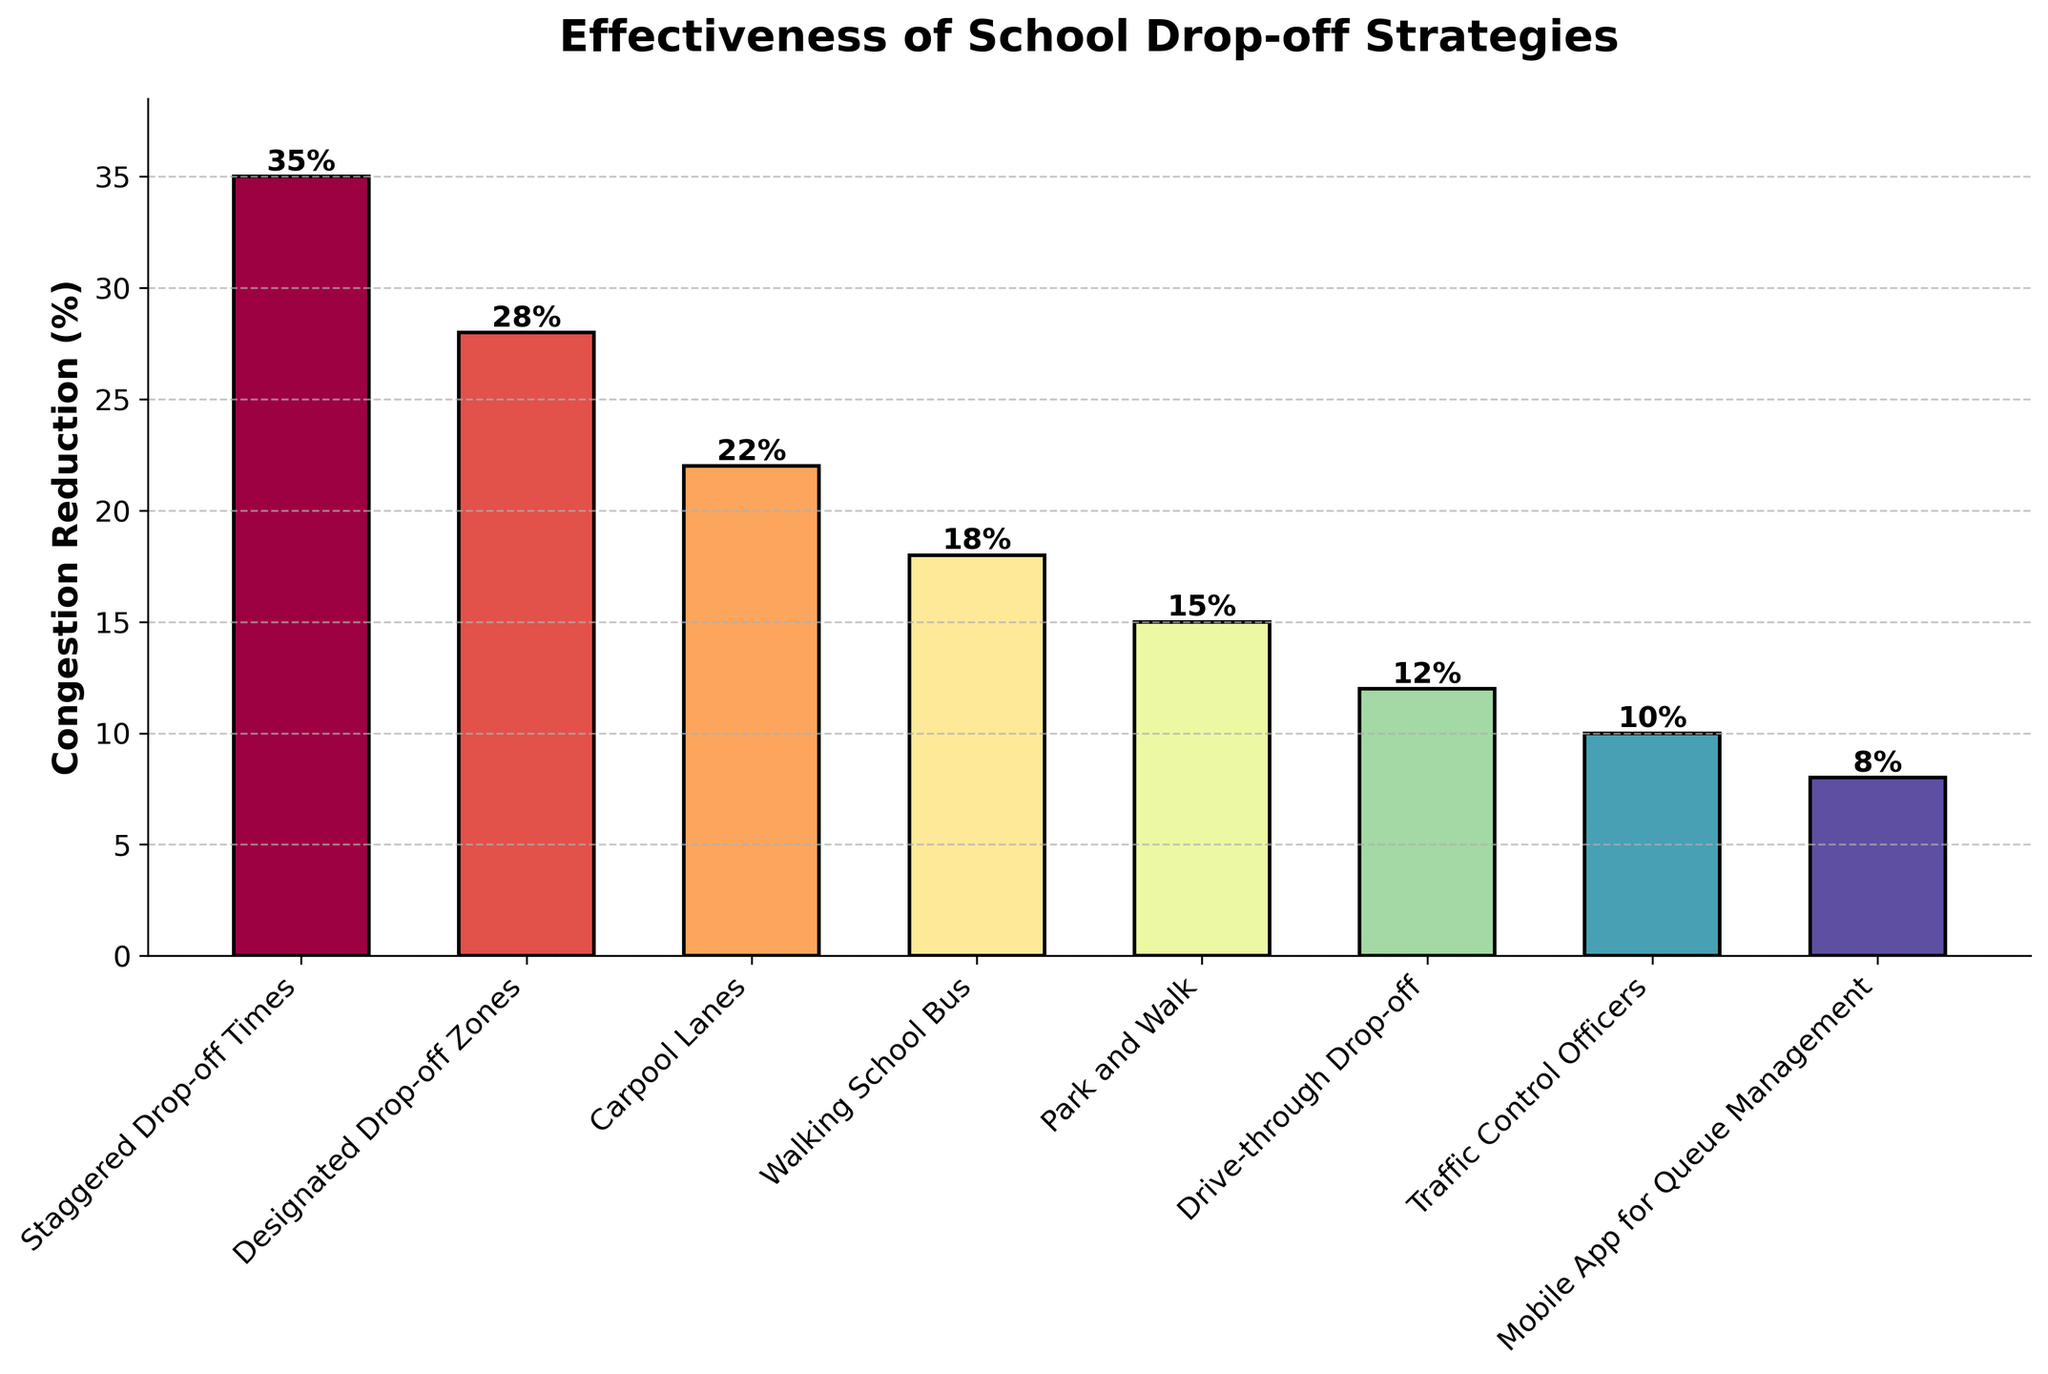Which strategy is the most effective in reducing congestion? The bar representing "Staggered Drop-off Times" is the tallest, implying the highest percentage of congestion reduction.
Answer: Staggered Drop-off Times How much more effective is "Staggered Drop-off Times" compared to "Drive-through Drop-off"? The congestion reduction for "Staggered Drop-off Times" is 35%, while for "Drive-through Drop-off" it is 12%. The difference is 35% - 12% = 23%.
Answer: 23% What is the total congestion reduction percentage of the top three strategies combined? The top three strategies are "Staggered Drop-off Times" (35%), "Designated Drop-off Zones" (28%), and "Carpool Lanes" (22%). Summing these gives 35% + 28% + 22% = 85%.
Answer: 85% Which strategy out of "Walking School Bus" and "Park and Walk" has a greater congestion reduction percentage? The bar for "Walking School Bus" shows an 18% reduction, while the bar for "Park and Walk" shows a 15% reduction. 18% is greater than 15%.
Answer: Walking School Bus What is the average congestion reduction percentage across all strategies? There are 8 strategies with the following percentages: 35, 28, 22, 18, 15, 12, 10, and 8. The sum is 148, and the average is 148 / 8 = 18.5%.
Answer: 18.5% How does the congestion reduction of "Traffic Control Officers" compare to "Mobile App for Queue Management"? "Traffic Control Officers" has a 10% reduction, while "Mobile App for Queue Management" has an 8% reduction. 10% is greater than 8%.
Answer: Traffic Control Officers Which strategy has the least effectiveness in reducing congestion, and what is its percentage? The shortest bar represents "Mobile App for Queue Management," indicating the least effectiveness at 8%.
Answer: Mobile App for Queue Management, 8% What is the combined congestion reduction percentage of all strategies that have above-average effectiveness? The above-average strategies are those with percentages greater than 18.5%: "Staggered Drop-off Times" (35%), "Designated Drop-off Zones" (28%), and "Carpool Lanes" (22%). Summing these gives 35% + 28% + 22% = 85%.
Answer: 85% What is the difference in congestion reduction percentage between the strategy with the highest and the second-highest effectiveness? The highest is "Staggered Drop-off Times" with 35%, and the second-highest is "Designated Drop-off Zones" with 28%. The difference is 35% - 28% = 7%.
Answer: 7% How many strategies have a congestion reduction percentage below 20%? Strategies with percentages below 20% are "Walking School Bus" (18%), "Park and Walk" (15%), "Drive-through Drop-off" (12%), "Traffic Control Officers" (10%), and "Mobile App for Queue Management" (8%). There are 5 such strategies.
Answer: 5 